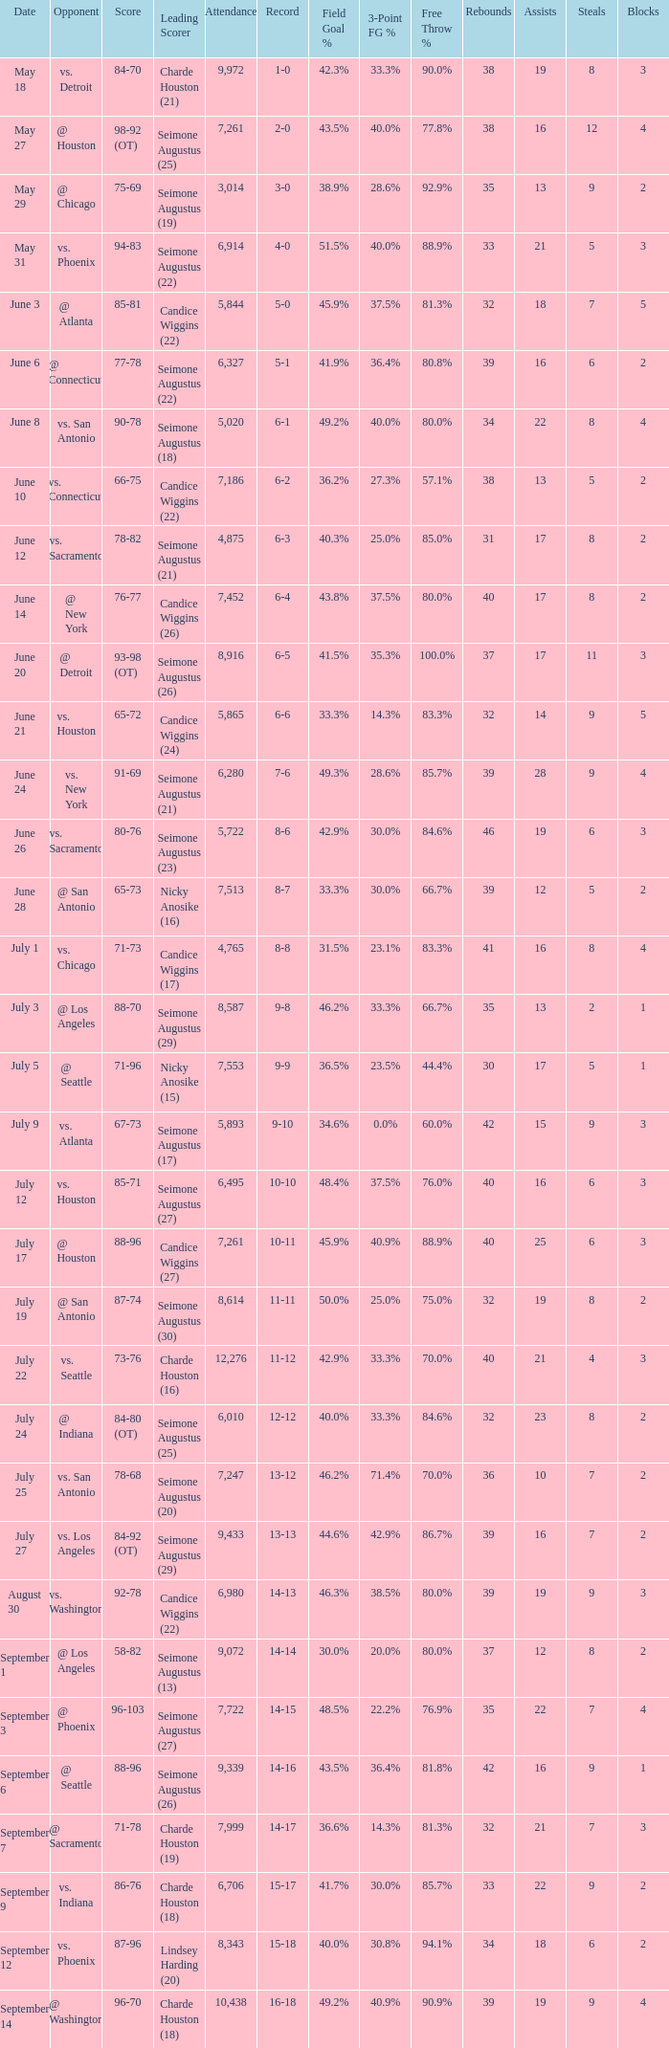Which Leading Scorer has an Opponent of @ seattle, and a Record of 14-16? Seimone Augustus (26). 